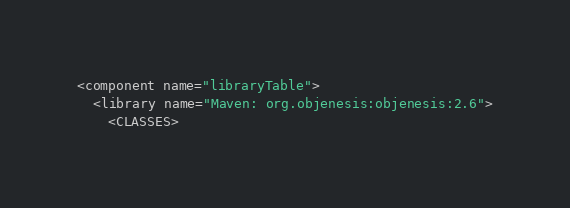Convert code to text. <code><loc_0><loc_0><loc_500><loc_500><_XML_><component name="libraryTable">
  <library name="Maven: org.objenesis:objenesis:2.6">
    <CLASSES></code> 